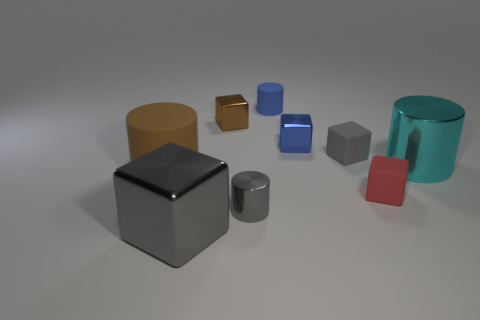Add 1 gray shiny cylinders. How many objects exist? 10 Subtract all cylinders. How many objects are left? 5 Add 7 big cyan cylinders. How many big cyan cylinders are left? 8 Add 4 red rubber things. How many red rubber things exist? 5 Subtract 1 gray cylinders. How many objects are left? 8 Subtract all large metallic cubes. Subtract all gray metal objects. How many objects are left? 6 